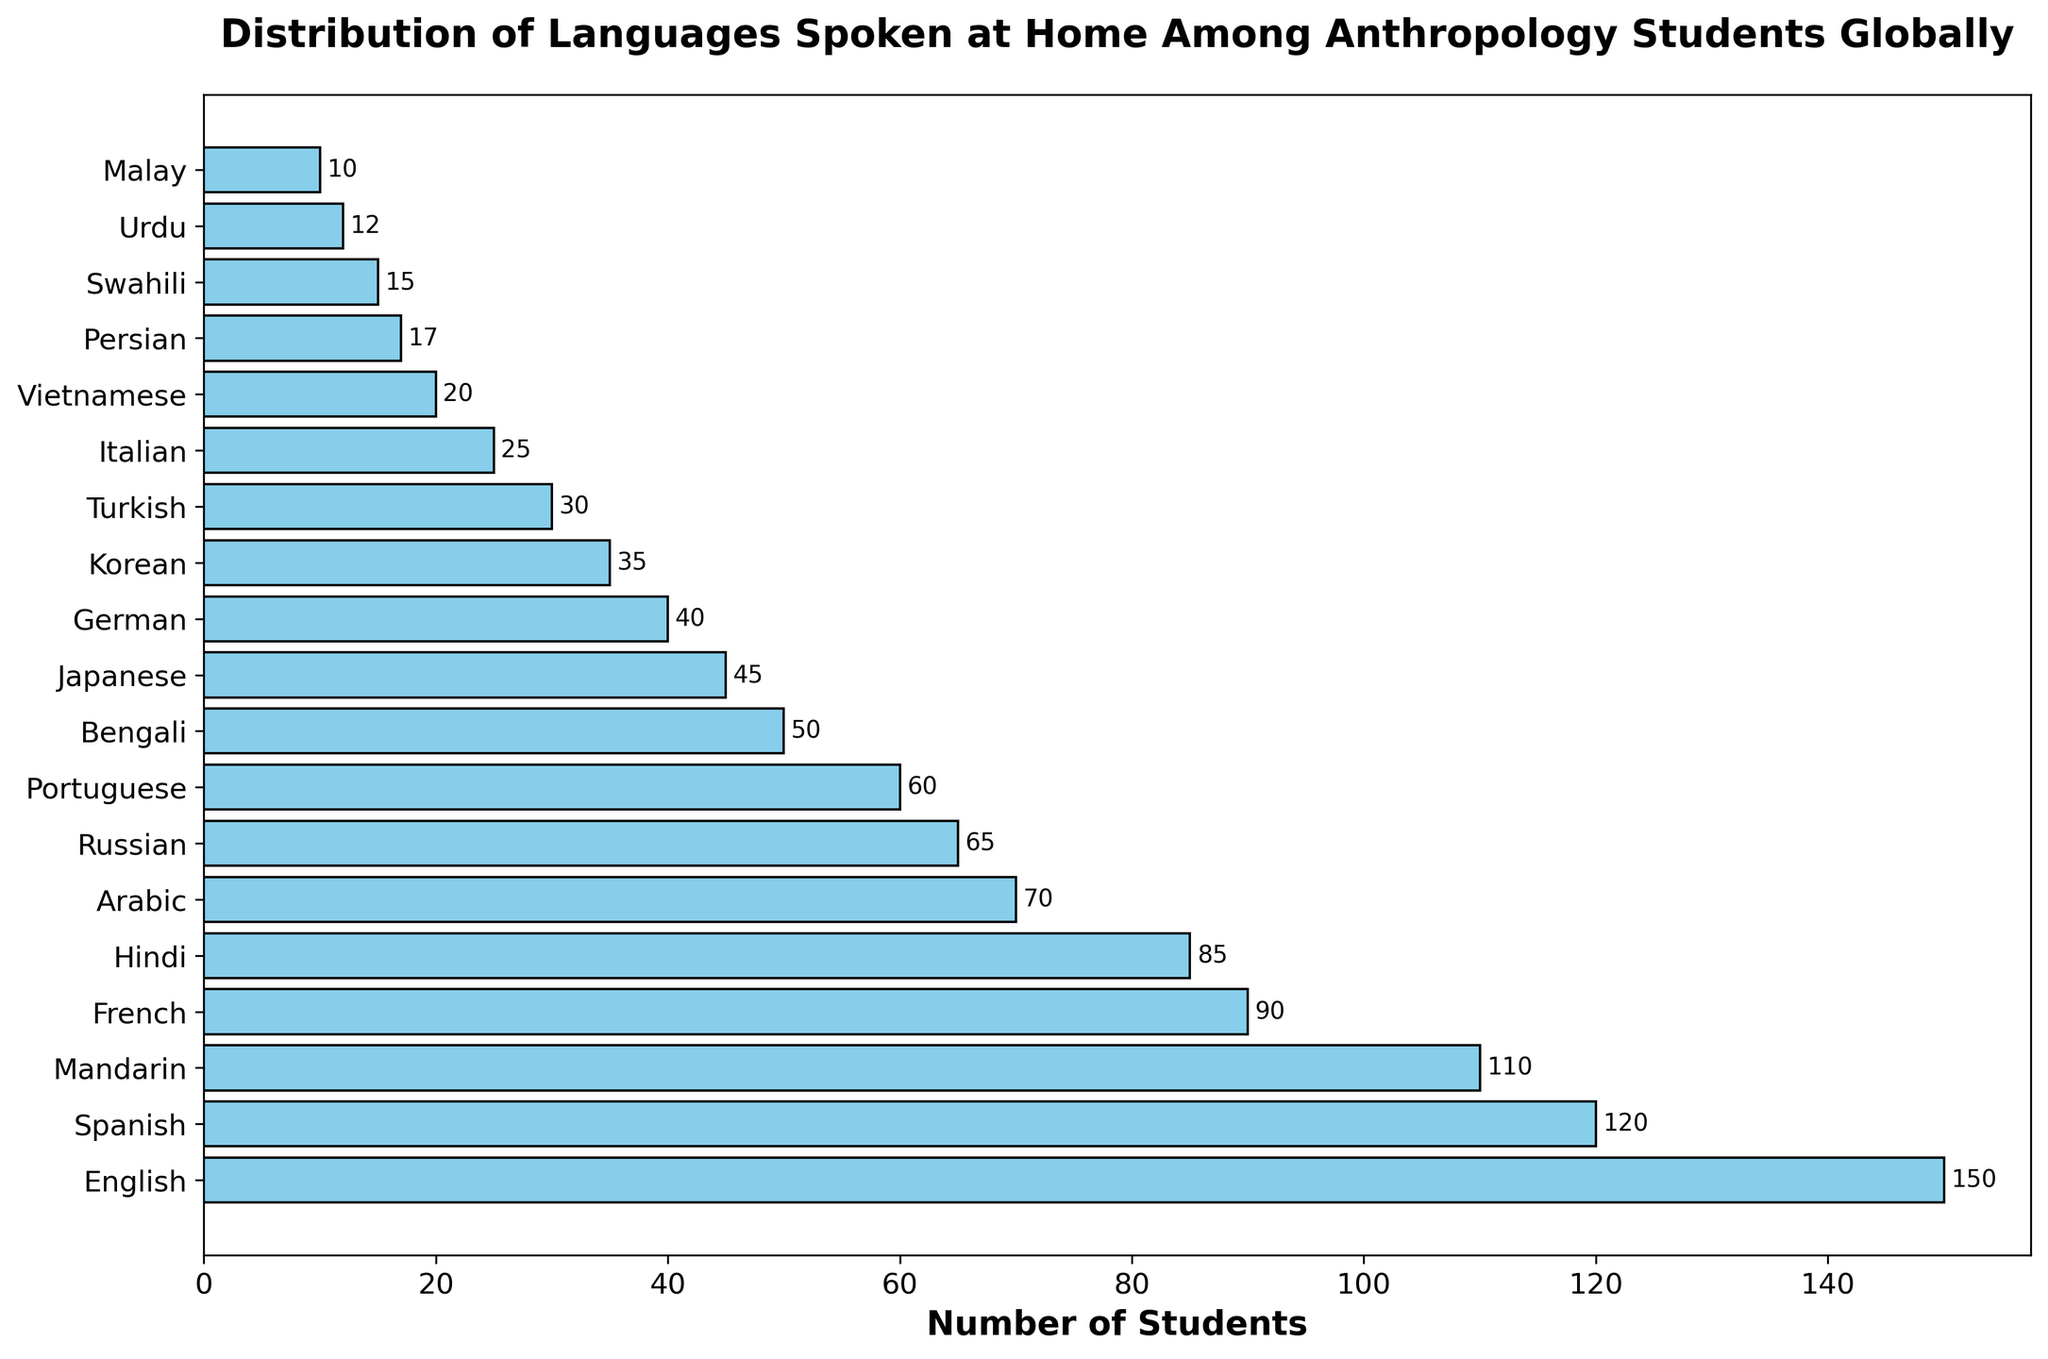Which language is spoken at home by the most anthropology students? Examine the bar lengths and look for the longest one. The longest bar represents the language spoken by the most students.
Answer: English How many more students speak Spanish at home compared to Japanese? Find the bars for Spanish (120 students) and Japanese (45 students). Subtract the number of students speaking Japanese from the number speaking Spanish: 120 - 45
Answer: 75 What is the total number of students who speak Mandarin and French at home? Locate the corresponding bars for Mandarin and French. Add the numbers together: 110 (Mandarin) + 90 (French) = 200
Answer: 200 Which language has fewer home speakers among anthropology students: German or Italian? Compare the bar lengths for the languages German (40 students) and Italian (25 students). The bar for Italian is shorter.
Answer: Italian How many languages are spoken at home by exactly 50 or more students? Count the number of languages whose bars have lengths corresponding to 50 or more students. These languages are: English, Spanish, Mandarin, French, Hindi, Arabic, Russian, Portuguese, and Bengali. This makes 9 languages.
Answer: 9 What is the combined number of students speaking Arabic, Russian, and Turkish at home? Sum the number of students speaking these languages. Arabic (70) + Russian (65) + Turkish (30) = 165
Answer: 165 Are there more students speaking French or Hindi at home? Compare the bar lengths or the numbers for French (90 students) and Hindi (85 students). The French bar is longer.
Answer: French Which language has the shortest bar and how many students speak it at home? Look for the shortest bar in the plot which represents Malay, and note the number next to it (10 students).
Answer: Malay, 10 What is the average number of students speaking the top three most spoken languages? Identify the top three languages by bar length: English (150), Spanish (120), and Mandarin (110). Calculate the average: (150 + 120 + 110) / 3 = 126.67
Answer: 126.67 By how many students does the number of Hindi speakers exceed that of Korean speakers? Find the bars for Hindi (85) and Korean (35), then subtract the number of Korean speakers from Hindi speakers: 85 - 35 = 50
Answer: 50 